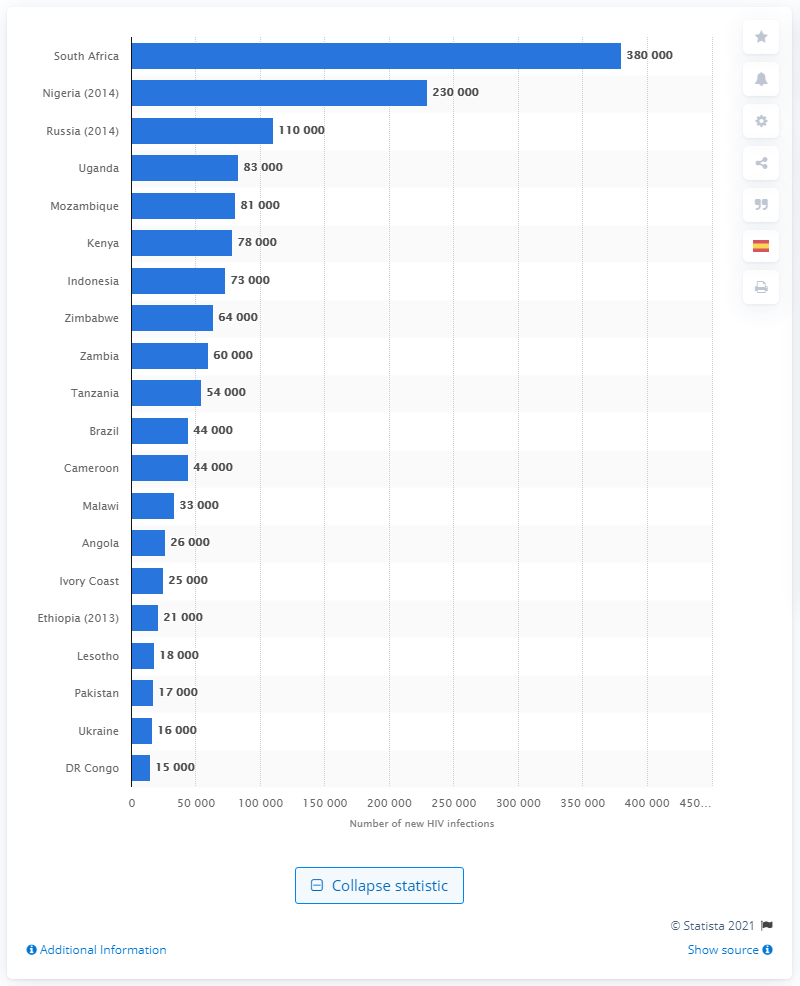Highlight a few significant elements in this photo. South Africa had the highest number of new HIV infections in 2015, among all countries. In 2015, there were an estimated 380,000 new HIV infections reported in South Africa. 